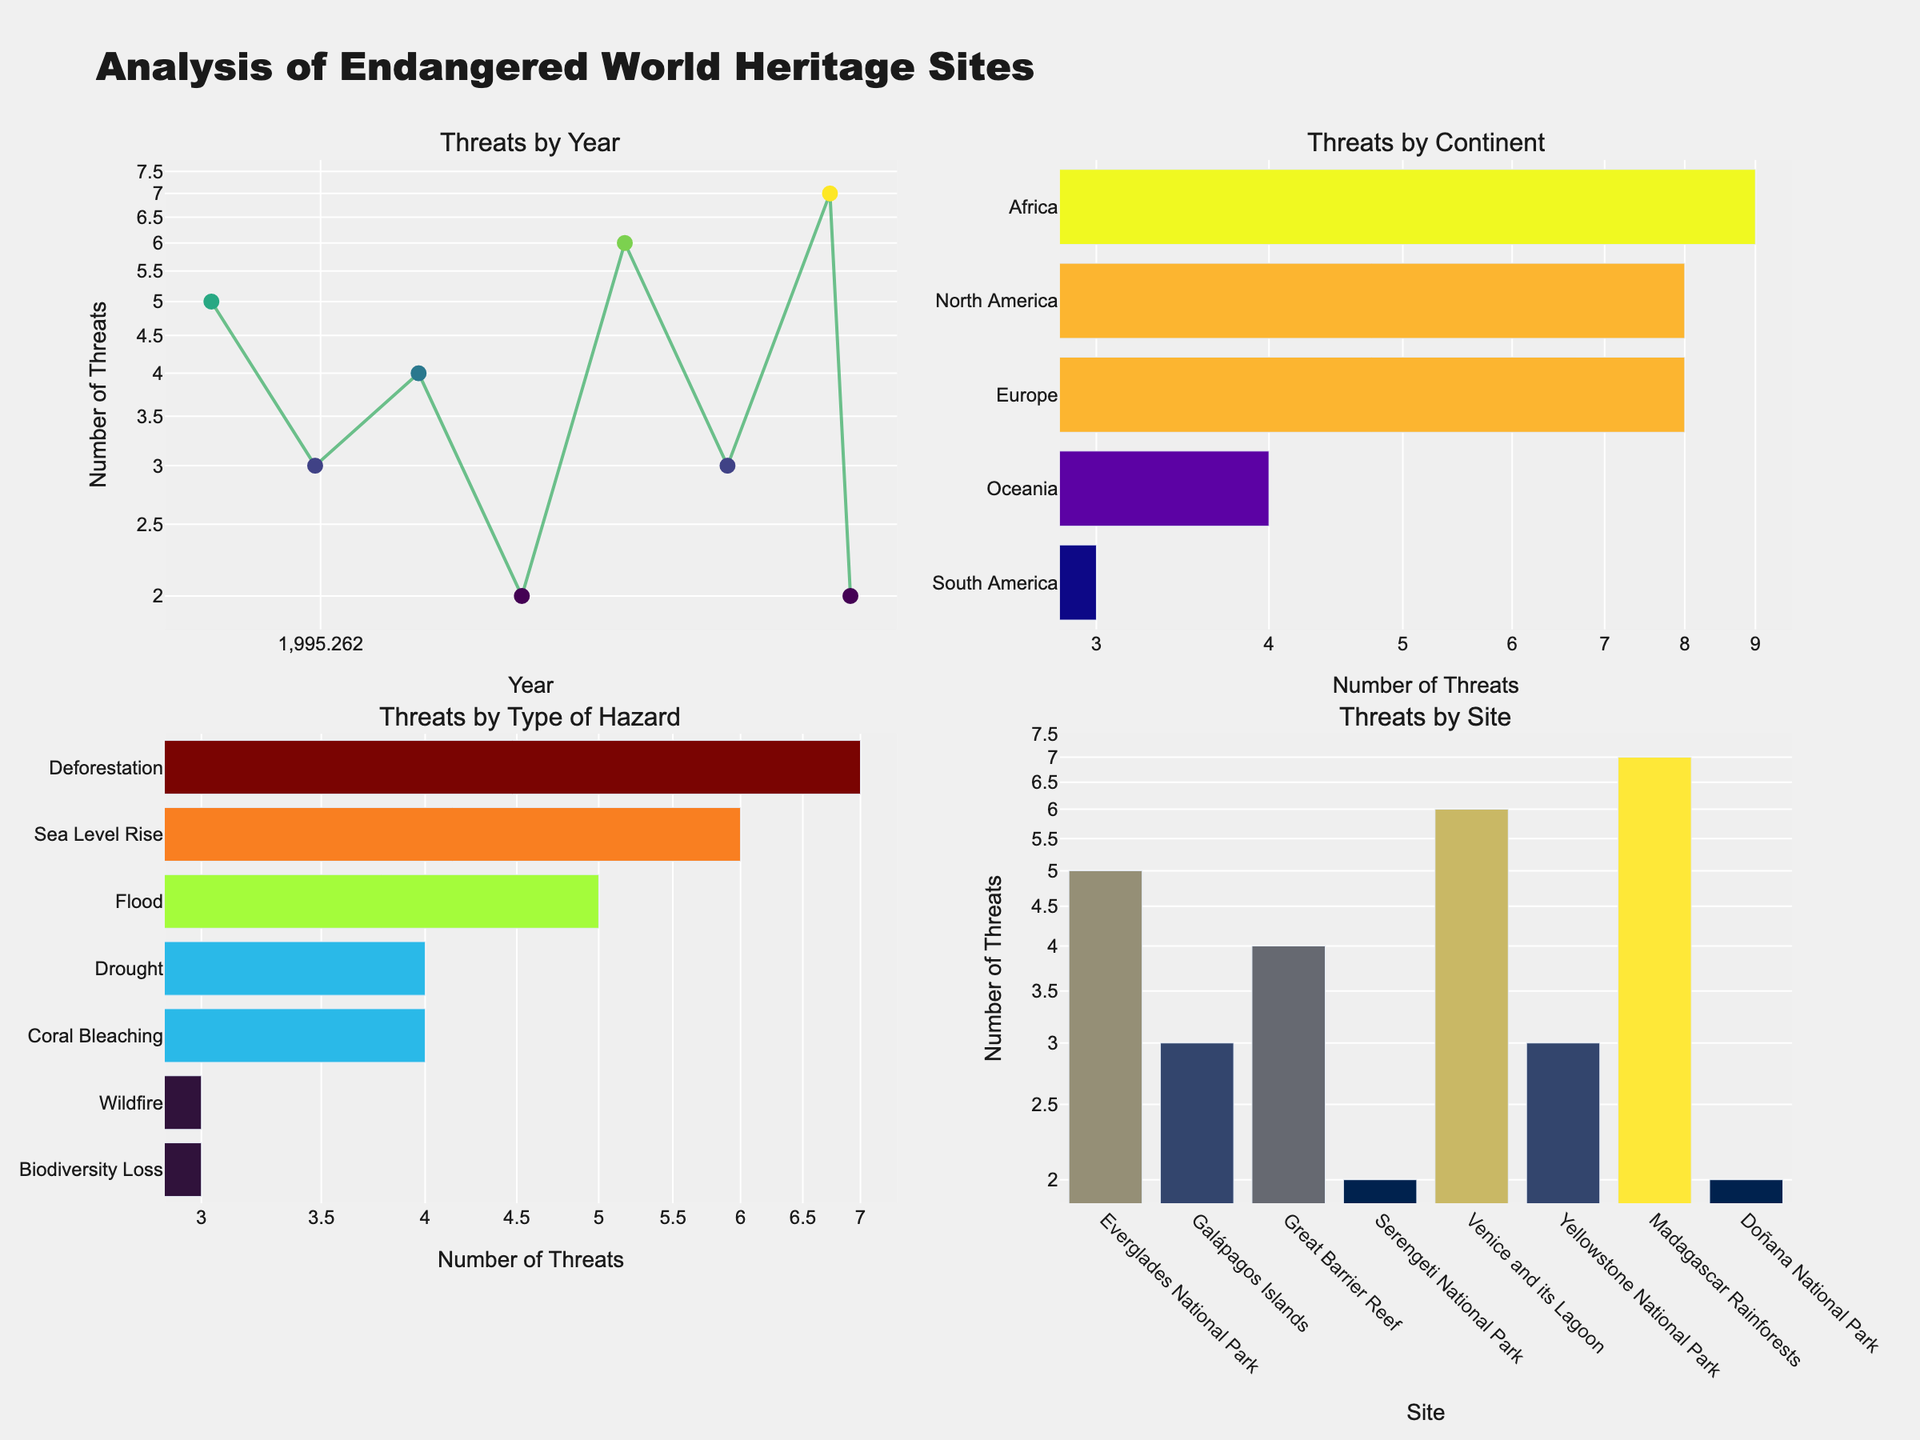How many total threats were reported for North America? There are two sites reported in North America: Everglades National Park with 5 threats and Yellowstone National Park with 3 threats. Adding these gives 5 + 3 = 8 threats.
Answer: 8 Which site faced the highest number of threats? By looking at the "Threats by Site" subplot in the bottom right, we see that Madagascar Rainforests had the highest number of threats with a value of 7.
Answer: Madagascar Rainforests What type of hazard caused the most threats overall? In the "Threats by Type of Hazard" subplot on the bottom left, the bar corresponding to Deforestation is the longest, indicating it has the highest number of threats, which is 7.
Answer: Deforestation Which continent had the fewest number of threats? In the "Threats by Continent" subplot on the top right, Oceania has the shortest bar, indicating it had the fewest threats with a total of 4.
Answer: Oceania What was the year with the highest number of threats reported? In the "Threats by Year" plot in the top left, the year 2010 has the highest value for the number of threats, which is 6.
Answer: 2010 Between Flood and Wildfire, which type of hazard had more reported threats? In the "Threats by Type of Hazard" subplot, the bar for Flood is at 5 and for Wildfire at 3. Thus, Flood had more threats reported.
Answer: Flood How many threats were reported in Africa in total? The "Threats by Continent" subplot shows Africa with a bar indicating 9 threats in total.
Answer: 9 Which year had more threats: 2000 or 2021? In the "Threats by Year" plot, the value for the year 2000 is 4, and for 2021 it is 2. Thus, 2000 had more threats.
Answer: 2000 What’s the total number of threats reported for sites in Europe? There are two European sites: Venice and its Lagoon with 6 threats and Doñana National Park with 2 threats. Adding these gives 6 + 2 = 8 threats.
Answer: 8 Which type of hazard had fewer threats: Coral Bleaching or Biodiversity Loss? In the "Threats by Type of Hazard" subplot, Coral Bleaching has 4 threats, while Biodiversity Loss has 3 threats. Therefore, Biodiversity Loss had fewer threats.
Answer: Biodiversity Loss 